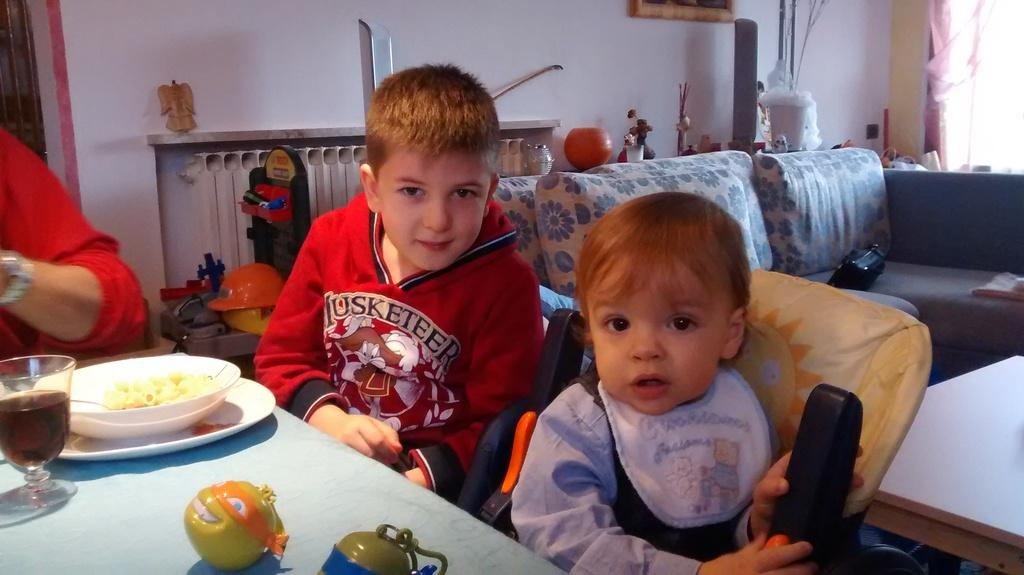Who is present in the image? There is a baby and a child in the image. What are the baby and child doing in the image? Both the baby and child are sitting on chairs. What is in front of the chairs? There is a table in front of the chairs. What can be found on the table? Food and a glass of juice are present on the table. What is visible behind the baby and child? There is a couch visible behind them. What channel is the baby watching on the television in the image? There is no television present in the image; it only features a baby, a child, chairs, a table, food, a glass of juice, and a couch. 